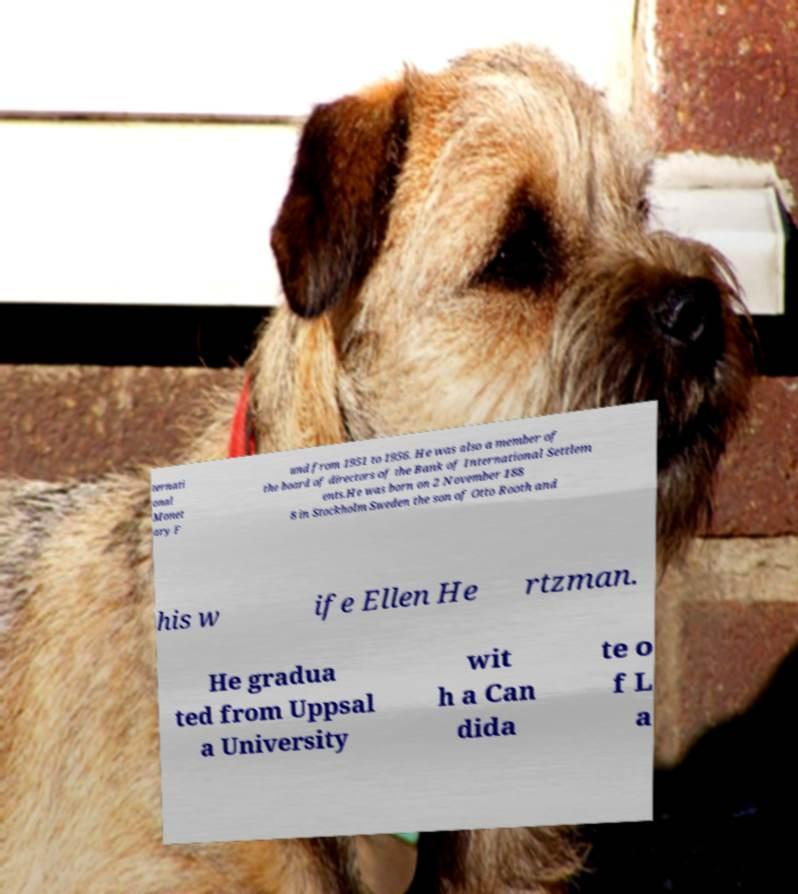There's text embedded in this image that I need extracted. Can you transcribe it verbatim? ternati onal Monet ary F und from 1951 to 1956. He was also a member of the board of directors of the Bank of International Settlem ents.He was born on 2 November 188 8 in Stockholm Sweden the son of Otto Rooth and his w ife Ellen He rtzman. He gradua ted from Uppsal a University wit h a Can dida te o f L a 